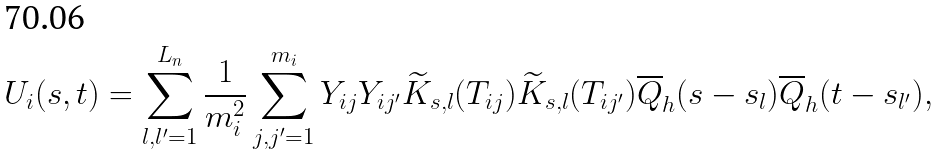Convert formula to latex. <formula><loc_0><loc_0><loc_500><loc_500>U _ { i } ( s , t ) = \sum _ { l , l ^ { \prime } = 1 } ^ { L _ { n } } \frac { 1 } { m _ { i } ^ { 2 } } \sum _ { j , j ^ { \prime } = 1 } ^ { m _ { i } } Y _ { i j } Y _ { i j ^ { \prime } } \widetilde { K } _ { s , l } ( T _ { i j } ) \widetilde { K } _ { s , l } ( T _ { i j ^ { \prime } } ) \overline { Q } _ { h } ( s - s _ { l } ) \overline { Q } _ { h } ( t - s _ { l ^ { \prime } } ) ,</formula> 